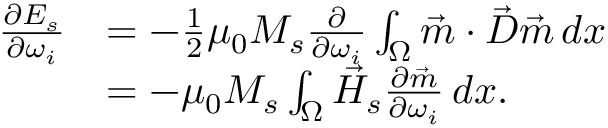Convert formula to latex. <formula><loc_0><loc_0><loc_500><loc_500>\begin{array} { r l } { \frac { \partial E _ { s } } { \partial \omega _ { i } } } & { = - \frac { 1 } { 2 } \mu _ { 0 } M _ { s } \frac { \partial } { \partial \omega _ { i } } \int _ { \Omega } \vec { m } \cdot \vec { D } \vec { m } \, d x } \\ & { = - \mu _ { 0 } M _ { s } \int _ { \Omega } \vec { H } _ { s } \frac { \partial \vec { m } } { \partial \omega _ { i } } \, d x . } \end{array}</formula> 